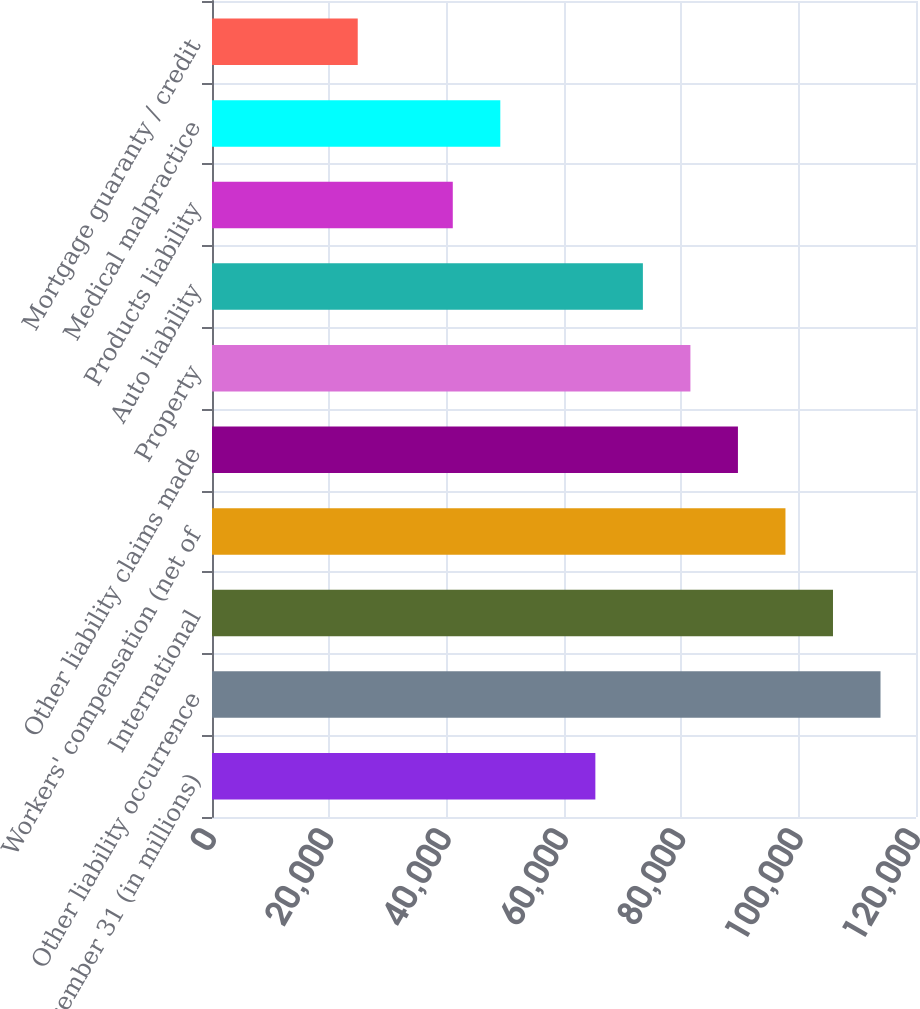Convert chart to OTSL. <chart><loc_0><loc_0><loc_500><loc_500><bar_chart><fcel>At December 31 (in millions)<fcel>Other liability occurrence<fcel>International<fcel>Workers' compensation (net of<fcel>Other liability claims made<fcel>Property<fcel>Auto liability<fcel>Products liability<fcel>Medical malpractice<fcel>Mortgage guaranty / credit<nl><fcel>65345.2<fcel>113951<fcel>105850<fcel>97748.8<fcel>89647.9<fcel>81547<fcel>73446.1<fcel>41042.5<fcel>49143.4<fcel>24840.7<nl></chart> 